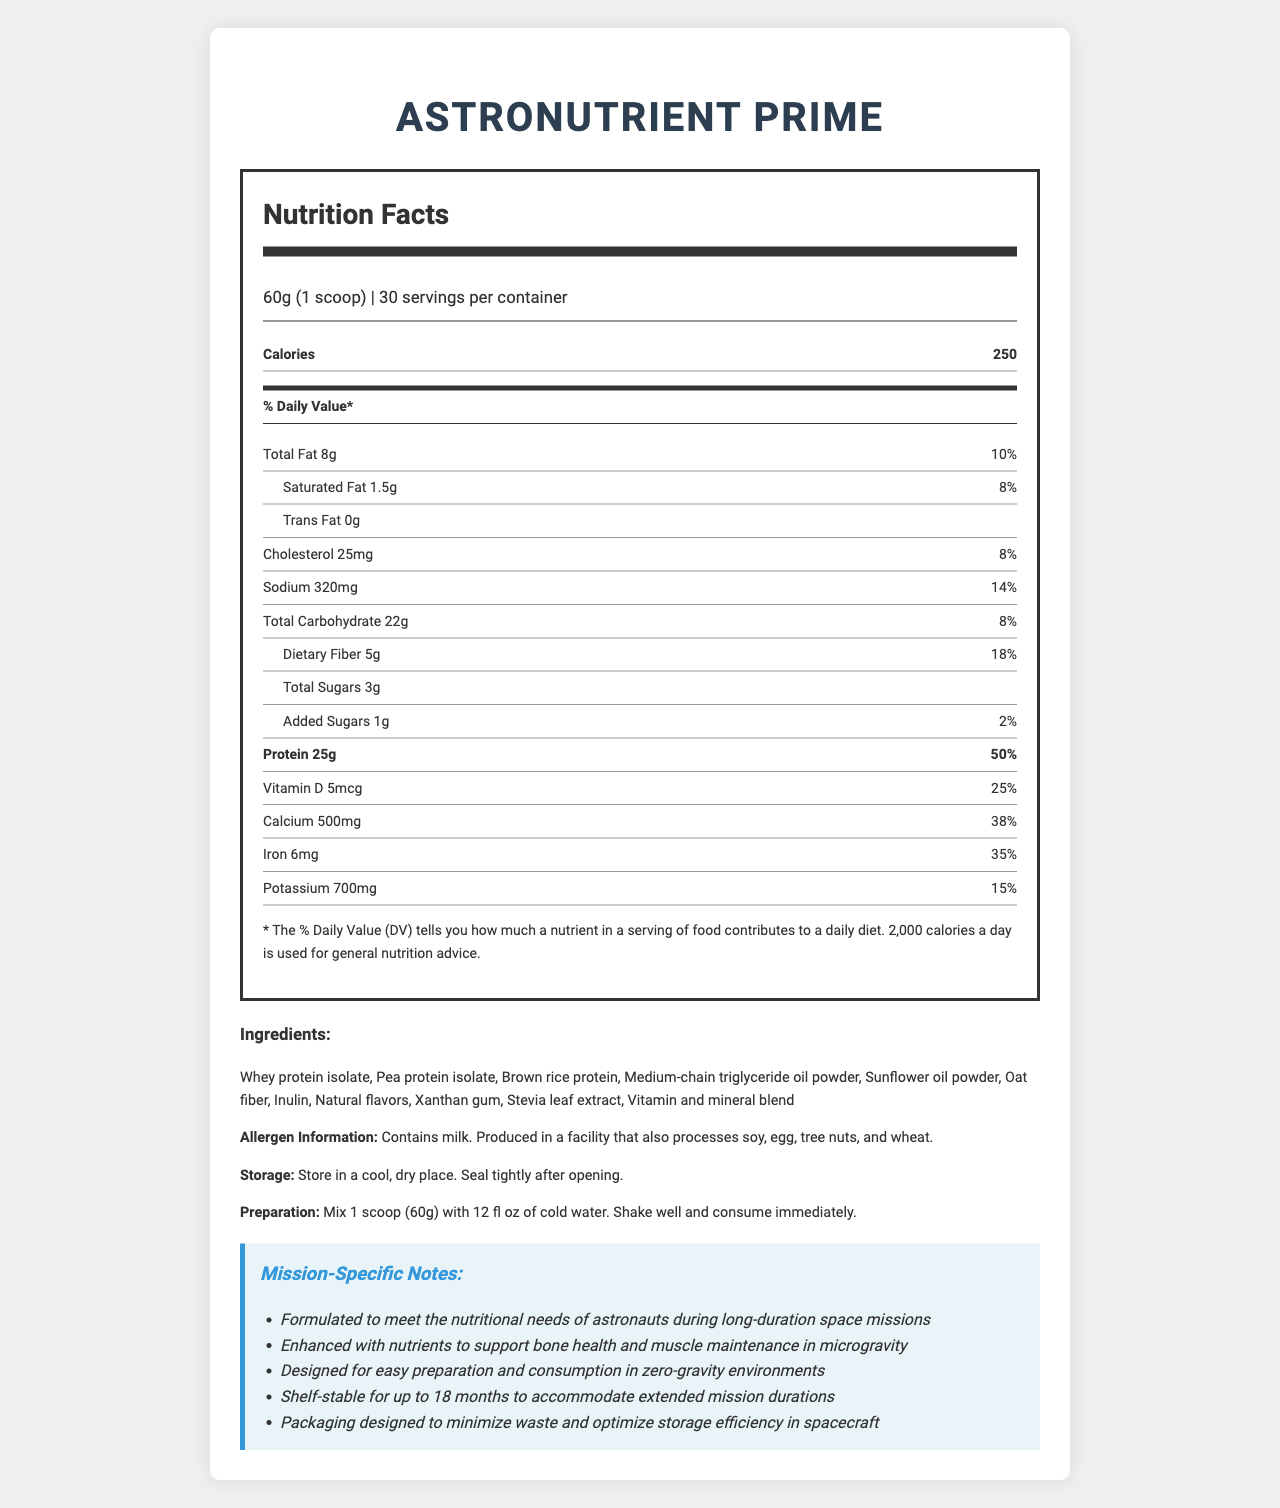1. What is the serving size of AstroNutrient Prime? The serving size is mentioned under the "Nutrition Facts" section at the top, as "60g (1 scoop)".
Answer: 60g (1 scoop) 2. How many servings are there per container? The number of servings per container is listed under the "Nutrition Facts" section and reads "30".
Answer: 30 3. What is the total calorie count per serving? The number of calories per serving is listed explicitly under "Calories" in the "Nutrition Facts" section.
Answer: 250 4. How many grams of dietary fiber are in each serving? The amount of dietary fiber per serving is provided under the "Total Carbohydrate" section, specifically listed as "Dietary Fiber".
Answer: 5g 5. What is the percentage daily value of protein in one serving? The percentage daily value of protein is listed as 50% under the "Protein" section in the "Nutrition Facts".
Answer: 50% 6. Which of these vitamins has the highest percentage daily value per serving: Vitamin D, Vitamin B12, Vitamin A, or Vitamin C? The document shows that the daily value for Vitamin B12 is 100%, which is higher than Vitamin D (25%), Vitamin A (50%), and Vitamin C (67%).
Answer: Vitamin B12 7. What is the total amount of fat in a single serving of AstroNutrient Prime? A. 5g B. 7g C. 8g D. 10g The total amount of fat per serving is listed as 8g under "Total Fat".
Answer: C. 8g 8. The Nutrition Facts label indicates that the meal replacement shake contains which of the following allergens? A. Soy B. Egg C. Milk D. None of the above According to the "Allergen Information" section, the product contains milk.
Answer: C. Milk 9. Is the product shelf-stable for up to 18 months? The shelf-stability is noted in the "Mission-Specific Notes" section, stating "Shelf-stable for up to 18 months to accommodate extended mission durations".
Answer: Yes 10. Which of the following does not contribute to the total carbohydrate content listed on the label? A. Inulin B. Oat fiber C. Total Sugars D. Medium-chain triglyceride oil powder Medium-chain triglyceride oil powder is listed as an ingredient but does not contribute to carbohydrates.
Answer: D. Medium-chain triglyceride oil powder 11. Can you determine the source of the natural flavors listed in the ingredients? The specific source of natural flavors is not provided in the document.
Answer: Cannot be determined 12. How should AstroNutrient Prime be stored? The storage instructions are provided toward the end of the document in the "Ingredients" section under the "Storage" label.
Answer: Store in a cool, dry place. Seal tightly after opening. 13. Summarize the main purpose and key features of AstroNutrient Prime. The summary captures the overall purpose and key features of the product as detailed in the "Mission-Specific Notes" section. The product is geared towards providing comprehensive nutrition to astronauts, emphasizing ease of use and storage efficiency in space missions.
Answer: AstroNutrient Prime is a high-protein meal replacement shake designed for astronauts on long-duration space missions. It contains a variety of essential nutrients and is formulated to support bone health and muscle maintenance in microgravity. It is easy to prepare and consume in zero-gravity environments, shelf-stable for up to 18 months, and comes in packaging designed to minimize waste and optimize storage efficiency in spacecraft. 